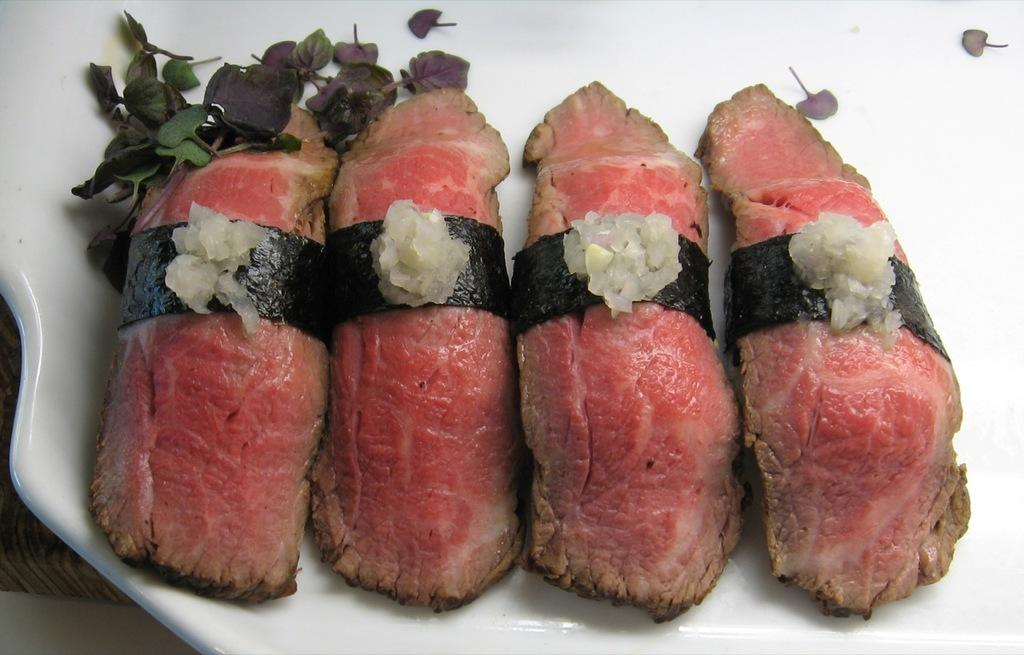What is present on the plate in the image? There are food items on the plate in the image. Are there any spiders crawling in the bath in the image? There is no bath or spiders present in the image; it features a plate with food items. 